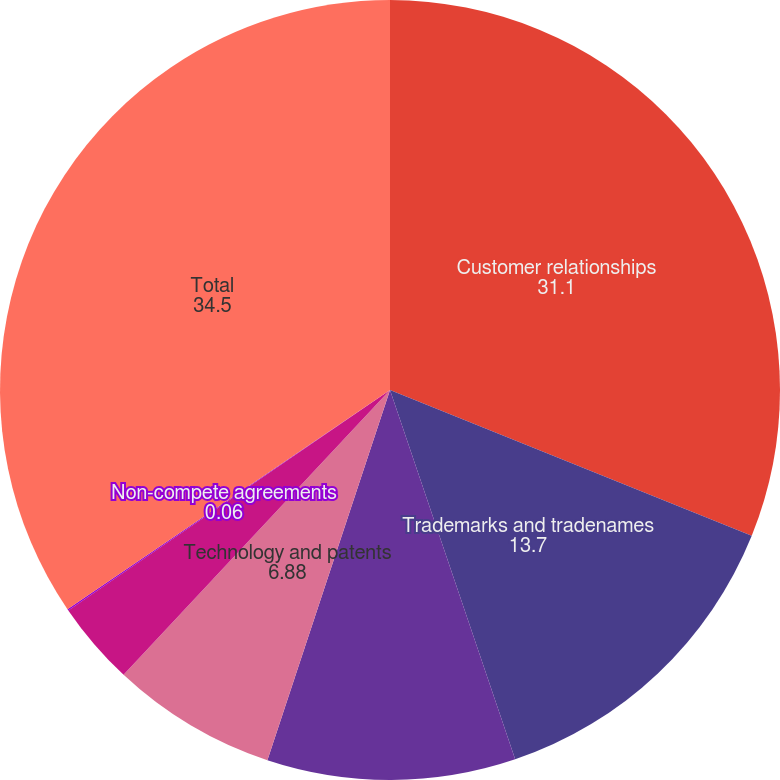Convert chart. <chart><loc_0><loc_0><loc_500><loc_500><pie_chart><fcel>Customer relationships<fcel>Trademarks and tradenames<fcel>Favorable contracts<fcel>Technology and patents<fcel>License costs<fcel>Non-compete agreements<fcel>Total<nl><fcel>31.1%<fcel>13.7%<fcel>10.29%<fcel>6.88%<fcel>3.47%<fcel>0.06%<fcel>34.5%<nl></chart> 